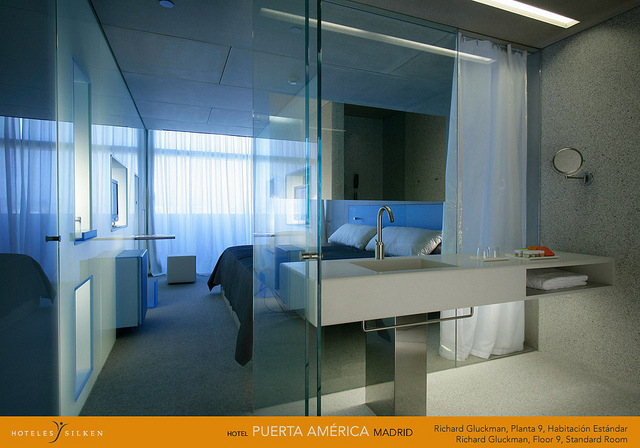Please identify all text content in this image. PUERTA AMERICA MADRID HOTEL Richard Room Standard 9 Floor Gluckman Richard Estandar Habitacion 9 Planta Gluckman BILXEN HOTELES 